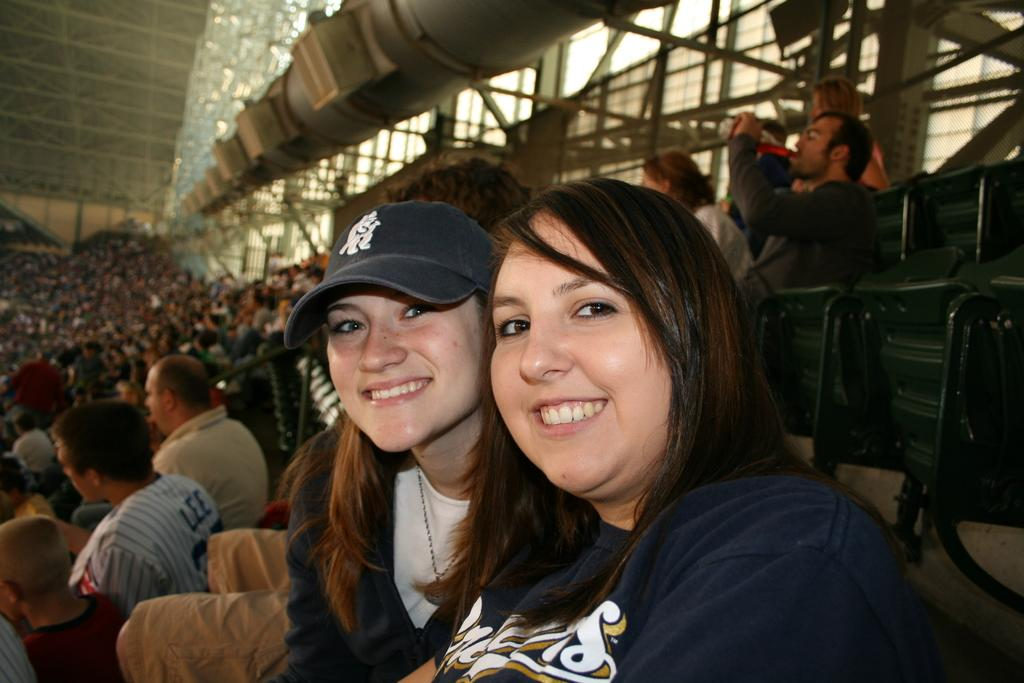How many people are in the image? There are people in the image, but the exact number is not specified. What is one person doing in the image? One person is drinking juice in the image. What type of objects can be seen in the image that are long and thin? There are rods in the image. What type of objects can be seen in the image that are connected by links? There are chains in the image. What type of objects can be seen in the image that have a specific function or purpose? There are devices in the image. What type of ornament is hanging from the rods in the image? There is no ornament hanging from the rods in the image; only rods and chains are mentioned. Can you see a robin in the image? There is no mention of a robin or any bird in the image. 